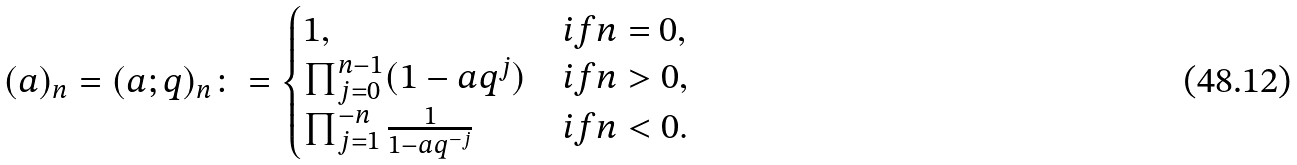Convert formula to latex. <formula><loc_0><loc_0><loc_500><loc_500>( a ) _ { n } = ( a ; q ) _ { n } \colon = \begin{cases} 1 , & i f n = 0 , \\ \prod _ { j = 0 } ^ { n - 1 } ( 1 - a q ^ { j } ) & i f n > 0 , \\ \prod _ { j = 1 } ^ { - n } \frac { 1 } { 1 - a q ^ { - j } } & i f n < 0 . \end{cases}</formula> 